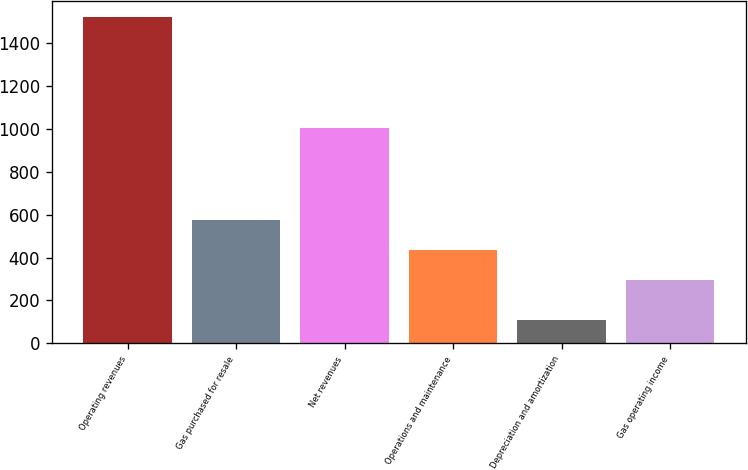Convert chart. <chart><loc_0><loc_0><loc_500><loc_500><bar_chart><fcel>Operating revenues<fcel>Gas purchased for resale<fcel>Net revenues<fcel>Operations and maintenance<fcel>Depreciation and amortization<fcel>Gas operating income<nl><fcel>1521<fcel>577.2<fcel>1003<fcel>436.1<fcel>110<fcel>295<nl></chart> 